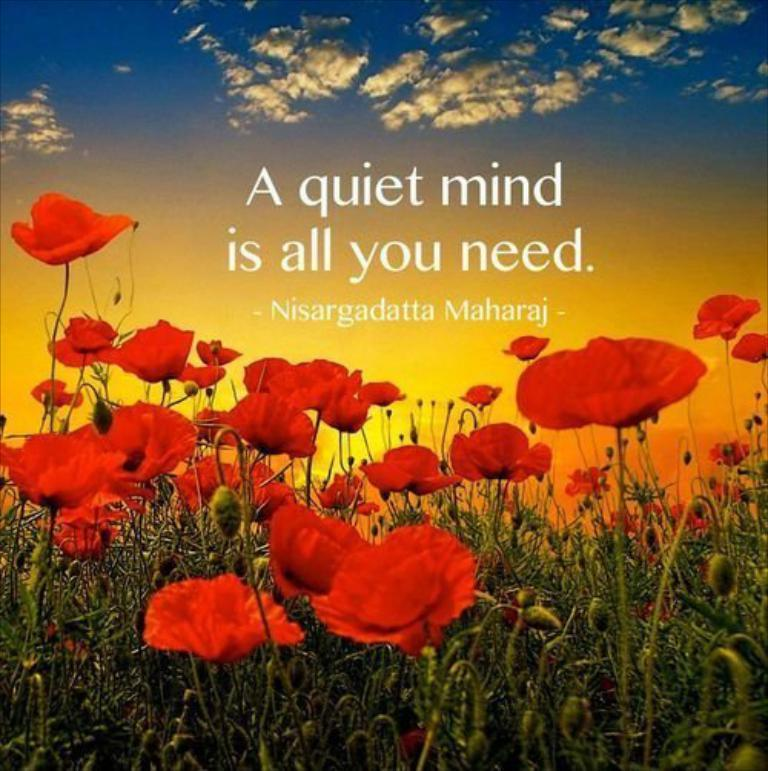What is featured on the poster in the image? The poster contains images of flowers. What are the flowers associated with? The flowers are associated with plants. How would you describe the sky in the image? The sky in the image is blue and cloudy. What else can be found on the poster besides the images of flowers? There is text on the poster. What color are the flowers on the poster? The flowers on the poster are red in color. What type of fuel is being used by the cow in the image? There is no cow present in the image; it features a poster with images of flowers. What kind of art is being created by the poster in the image? The poster itself is a form of art, as it contains images and text, but it is not actively creating any other art in the image. 